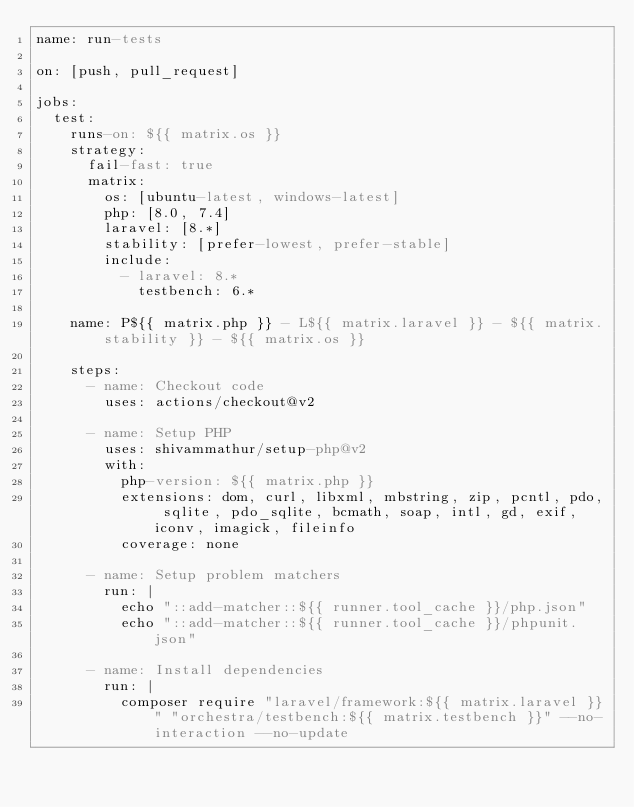Convert code to text. <code><loc_0><loc_0><loc_500><loc_500><_YAML_>name: run-tests

on: [push, pull_request]

jobs:
  test:
    runs-on: ${{ matrix.os }}
    strategy:
      fail-fast: true
      matrix:
        os: [ubuntu-latest, windows-latest]
        php: [8.0, 7.4]
        laravel: [8.*]
        stability: [prefer-lowest, prefer-stable]
        include:
          - laravel: 8.*
            testbench: 6.*

    name: P${{ matrix.php }} - L${{ matrix.laravel }} - ${{ matrix.stability }} - ${{ matrix.os }}

    steps:
      - name: Checkout code
        uses: actions/checkout@v2

      - name: Setup PHP
        uses: shivammathur/setup-php@v2
        with:
          php-version: ${{ matrix.php }}
          extensions: dom, curl, libxml, mbstring, zip, pcntl, pdo, sqlite, pdo_sqlite, bcmath, soap, intl, gd, exif, iconv, imagick, fileinfo
          coverage: none

      - name: Setup problem matchers
        run: |
          echo "::add-matcher::${{ runner.tool_cache }}/php.json"
          echo "::add-matcher::${{ runner.tool_cache }}/phpunit.json"

      - name: Install dependencies
        run: |
          composer require "laravel/framework:${{ matrix.laravel }}" "orchestra/testbench:${{ matrix.testbench }}" --no-interaction --no-update</code> 